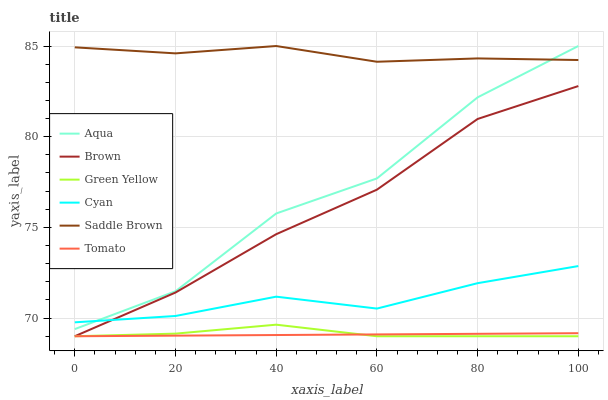Does Tomato have the minimum area under the curve?
Answer yes or no. Yes. Does Saddle Brown have the maximum area under the curve?
Answer yes or no. Yes. Does Brown have the minimum area under the curve?
Answer yes or no. No. Does Brown have the maximum area under the curve?
Answer yes or no. No. Is Tomato the smoothest?
Answer yes or no. Yes. Is Aqua the roughest?
Answer yes or no. Yes. Is Brown the smoothest?
Answer yes or no. No. Is Brown the roughest?
Answer yes or no. No. Does Tomato have the lowest value?
Answer yes or no. Yes. Does Aqua have the lowest value?
Answer yes or no. No. Does Saddle Brown have the highest value?
Answer yes or no. Yes. Does Brown have the highest value?
Answer yes or no. No. Is Green Yellow less than Aqua?
Answer yes or no. Yes. Is Saddle Brown greater than Brown?
Answer yes or no. Yes. Does Cyan intersect Aqua?
Answer yes or no. Yes. Is Cyan less than Aqua?
Answer yes or no. No. Is Cyan greater than Aqua?
Answer yes or no. No. Does Green Yellow intersect Aqua?
Answer yes or no. No. 